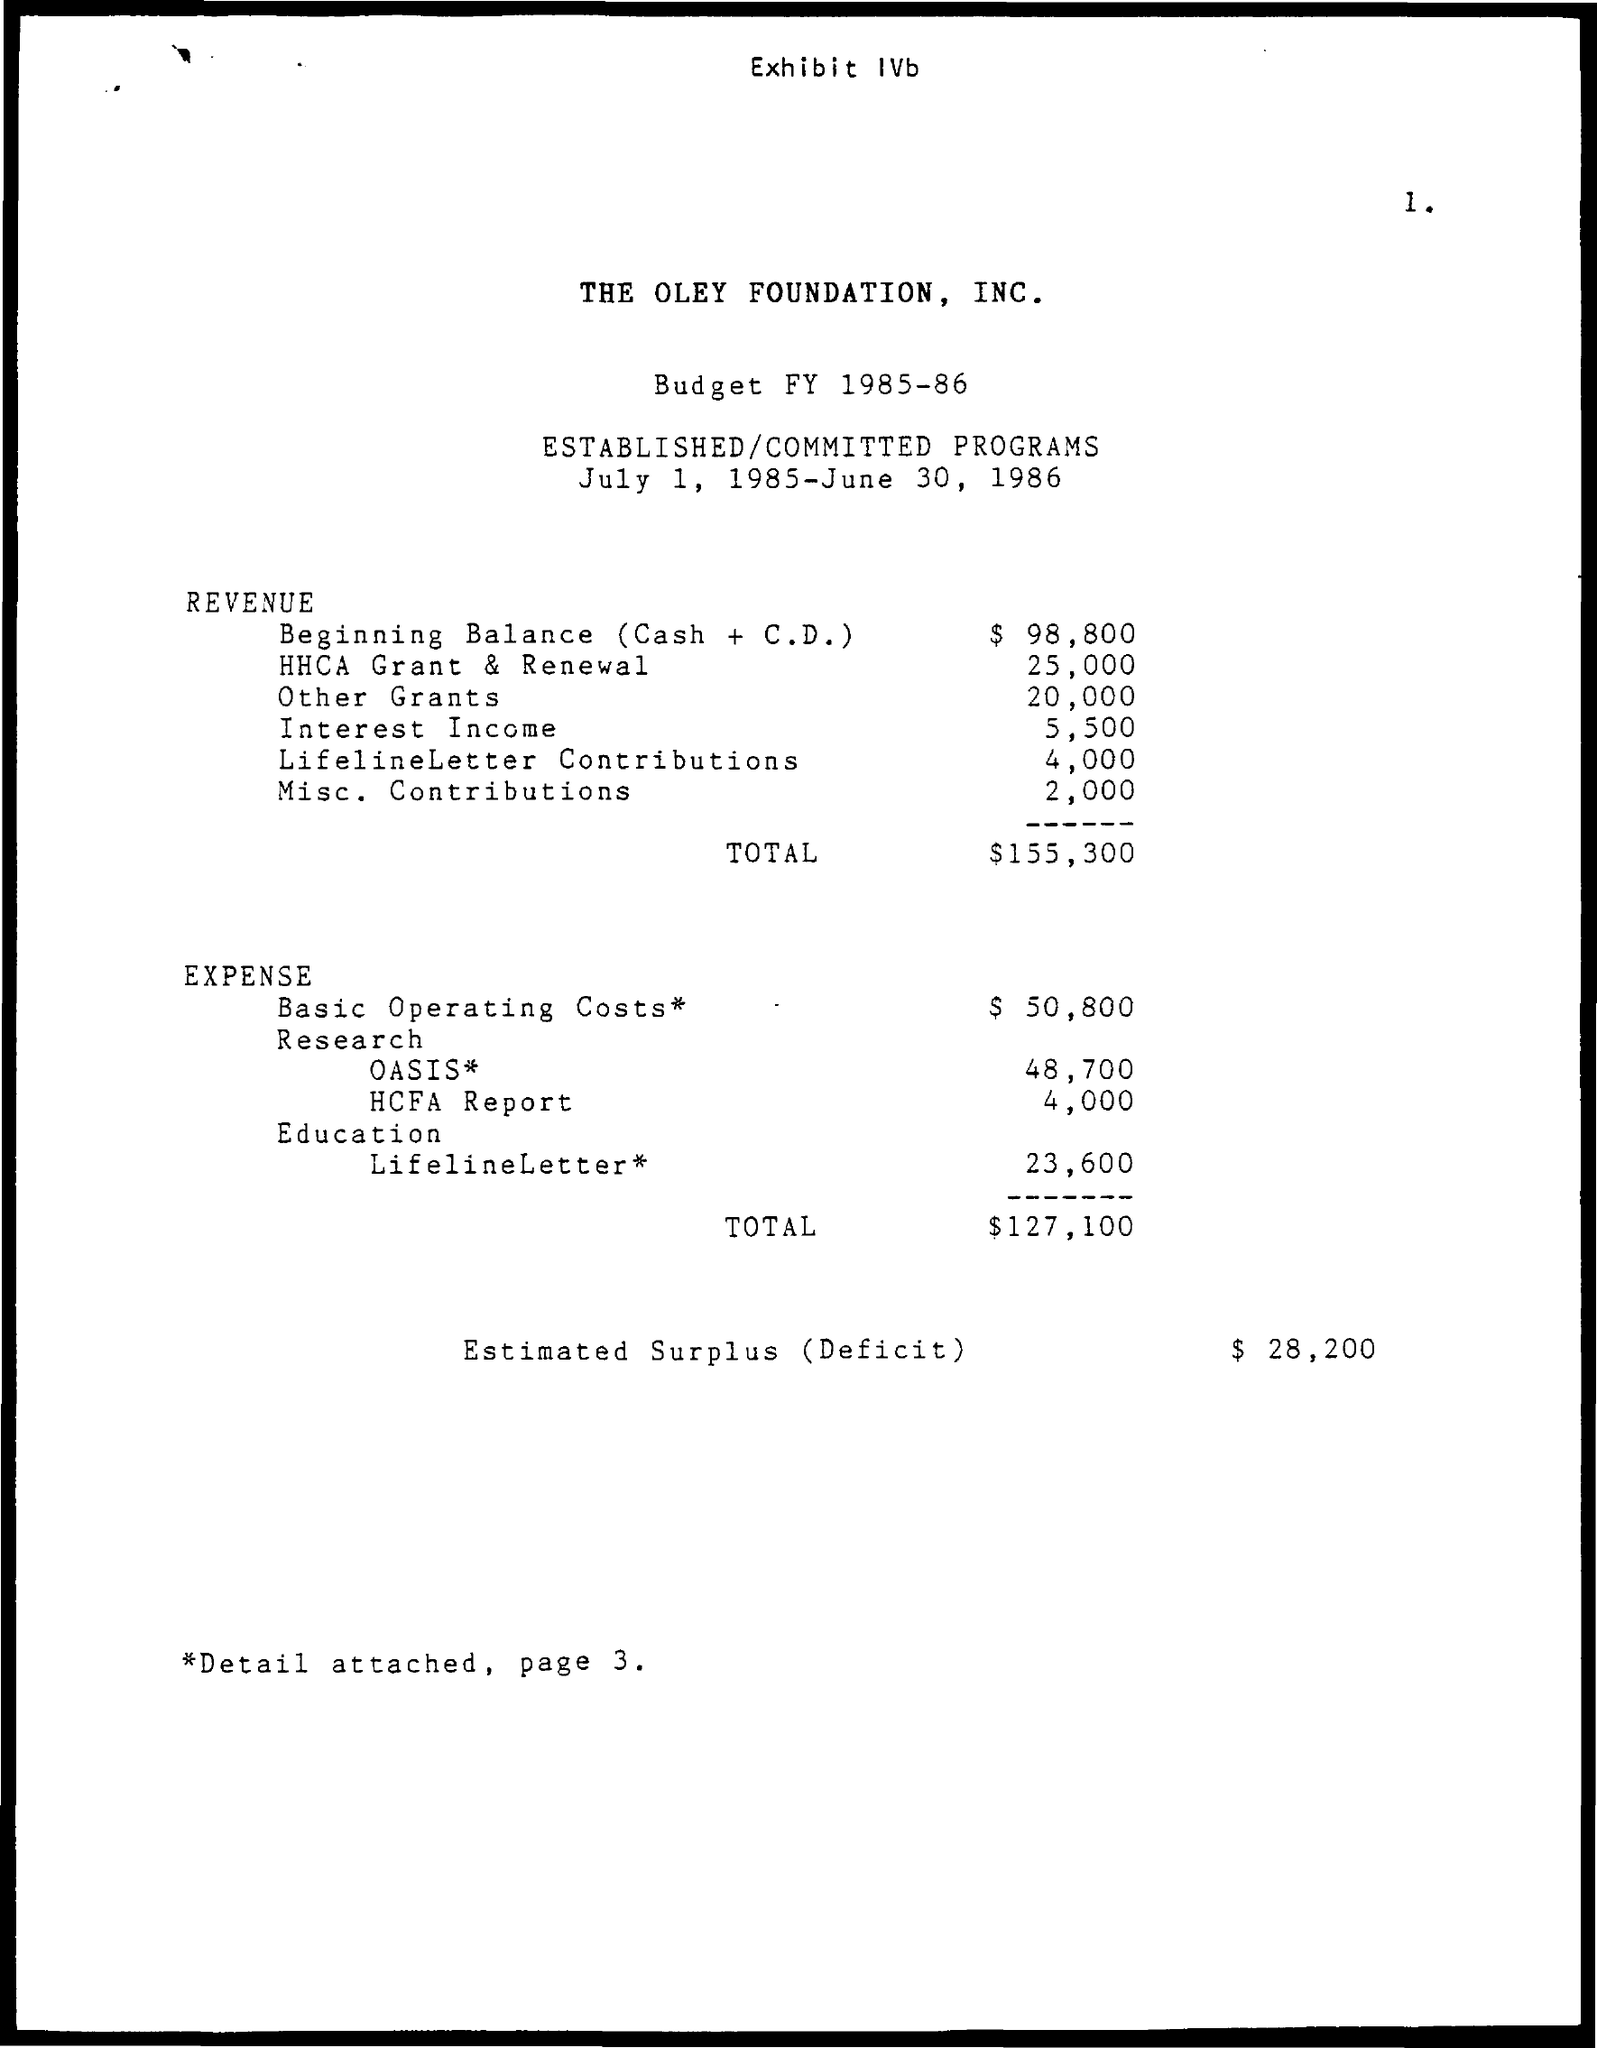What is the amount mentioned for beginning balance (cash+c.d.) in the revenue ?
Ensure brevity in your answer.  $ 98,800. What is the given budget for hhca grant&renewal as mentioned in the given revenue ?
Provide a short and direct response. $ 25,000. What is the budget for the other grants as mentioned in the given revenue ?
Ensure brevity in your answer.  $ 20,000. What is the budget for the interest income as mentioned in the given revenue ?
Ensure brevity in your answer.  $ 5,500. What is the total budget mentioned in the given revenue ?
Offer a very short reply. $ 155,300. What is the budget of expense for basic operating costs ?
Offer a very short reply. $50,800. 